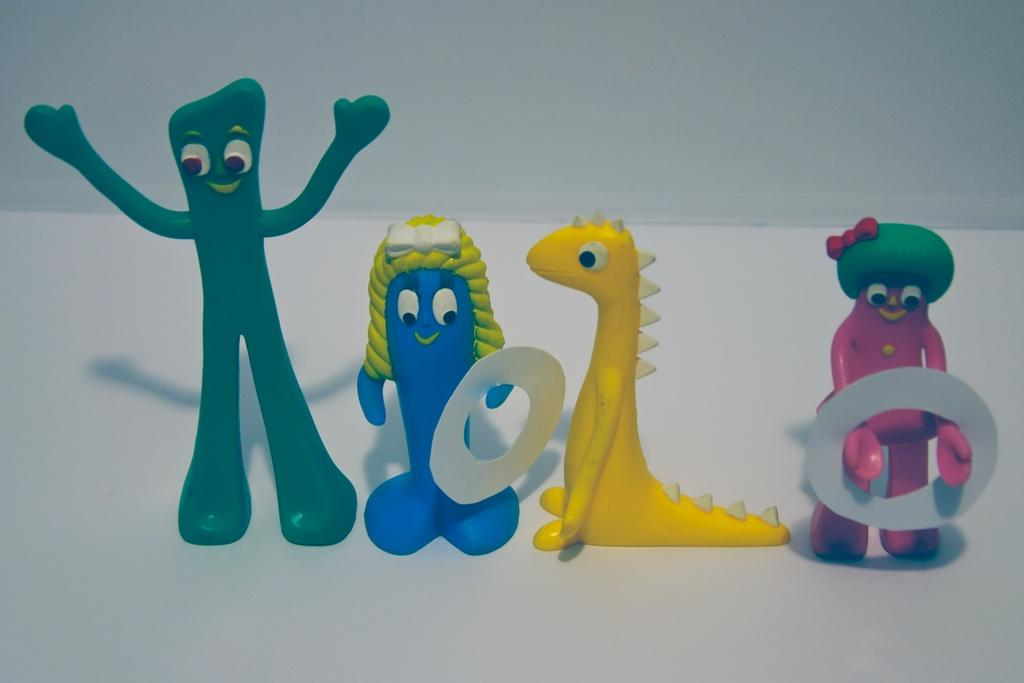What objects are on the white surface in the image? There are toys on a white surface in the image. What color is the background of the image? The background of the image is white. Where is the jail located in the image? There is no jail present in the image; it features toys on a white surface with a white background. What type of slip can be seen on the toys in the image? There are no slips on the toys in the image; it only shows toys on a white surface with a white background. 